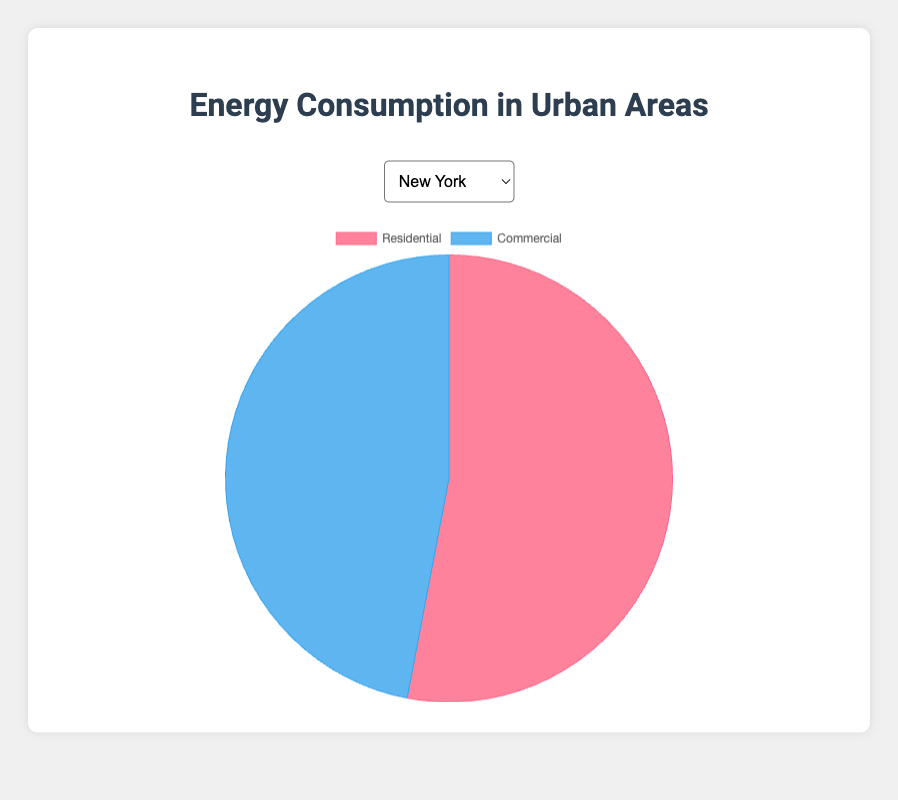Which city has an equal division of residential and commercial energy consumption? By looking at each city's breakdown, Chicago has 50% residential and 50% commercial energy consumption, making it the only city with an equal division.
Answer: Chicago Which city has the highest residential energy consumption percentage? By comparing the residential percentages of all cities, San Antonio at 58% has the highest residential energy consumption.
Answer: San Antonio Which city has the smallest difference between residential and commercial energy consumption? By calculating the differences for each city: Chicago has the smallest difference, as both are 50%, making the difference 0.
Answer: Chicago What is the average residential energy consumption across all cities? Adding all residential percentages (53+55+50+57+52+54+58+51+56+53) equals 539. Dividing by the number of cities (10), the average is 539/10 = 53.9.
Answer: 53.9 What percentage of total energy consumption is accounted for by the commercial sector in Houston and Dallas combined? For Houston: 43%, and Dallas: 44%. Combined: 43 + 44 = 87%.
Answer: 87 If you combine the residential energy use of Phoenix and San Diego, what percentage of their combined total energy is residential? Adding residential: 52 (Phoenix) + 51 (San Diego) = 103, and total energy: 100 + 100 = 200. The percentage is (103/200)*100 = 51.5%.
Answer: 51.5 Which cities have a residential consumption percentage over 55%? Reviewing each city reveals: Houston (57%), San Antonio (58%), and Dallas (56%) have residential consumption over 55%.
Answer: Houston, San Antonio, Dallas Is the commercial energy usage in New York greater than in San Diego? New York has 47% for commercial, while San Diego has 49%. Since 49 > 47, San Diego's commercial usage is greater.
Answer: No Which city has a residential energy consumption less than 52%? Reviewing each city's residential percentage, San Diego at 51% is the only city under 52%.
Answer: San Diego If residential consumption in Philadelphia increased by 2%, what would be the new residential and commercial figures? Current residential: 54%, increased by 2%: 54 + 2 = 56%. Since the total must be 100%, commercial becomes 100 - 56 = 44%.
Answer: Residential: 56%, Commercial: 44% 